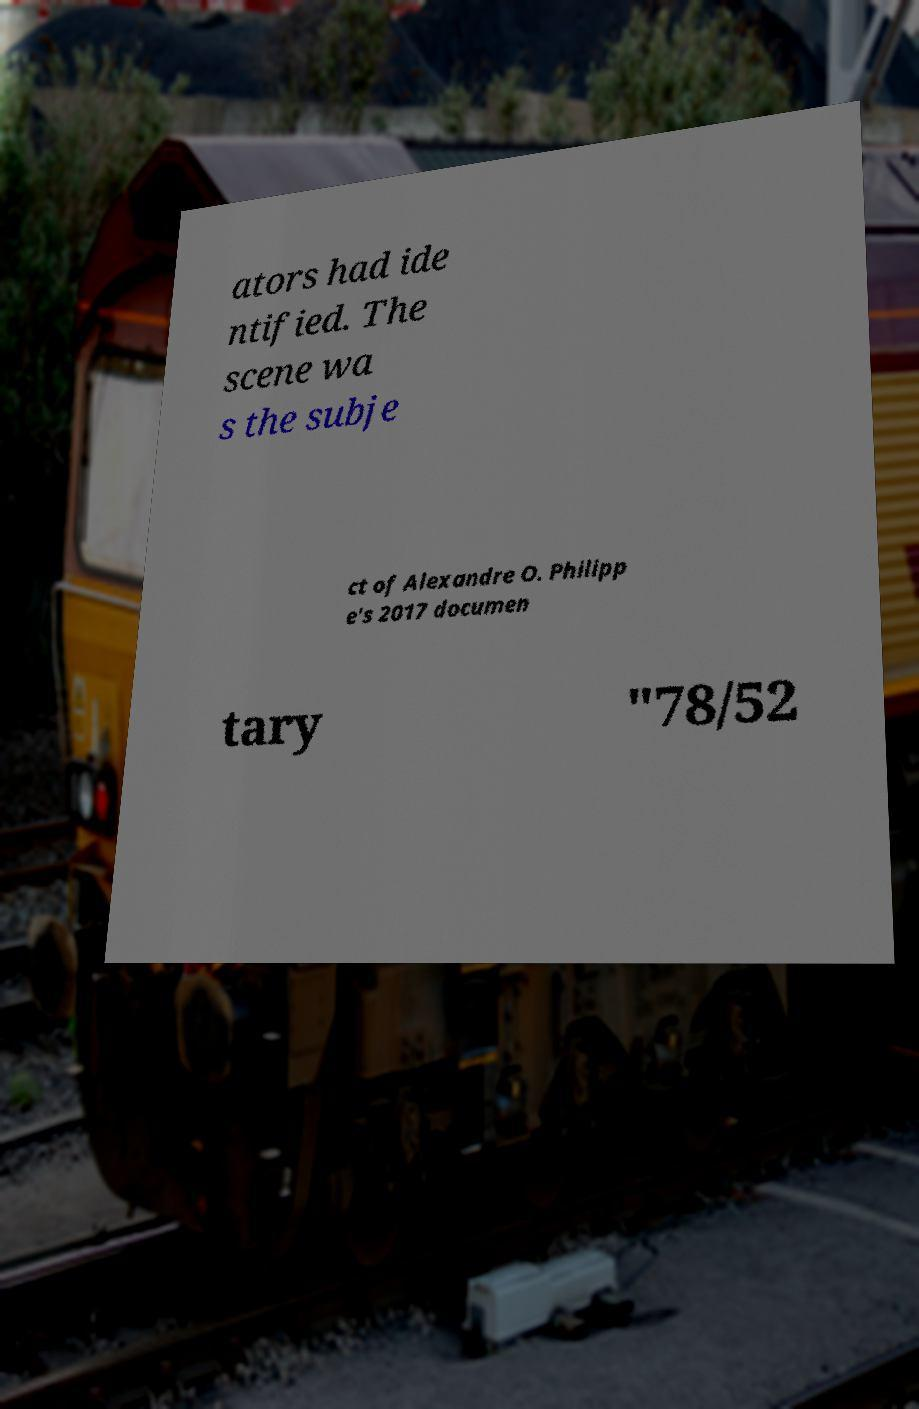Could you assist in decoding the text presented in this image and type it out clearly? ators had ide ntified. The scene wa s the subje ct of Alexandre O. Philipp e's 2017 documen tary "78/52 